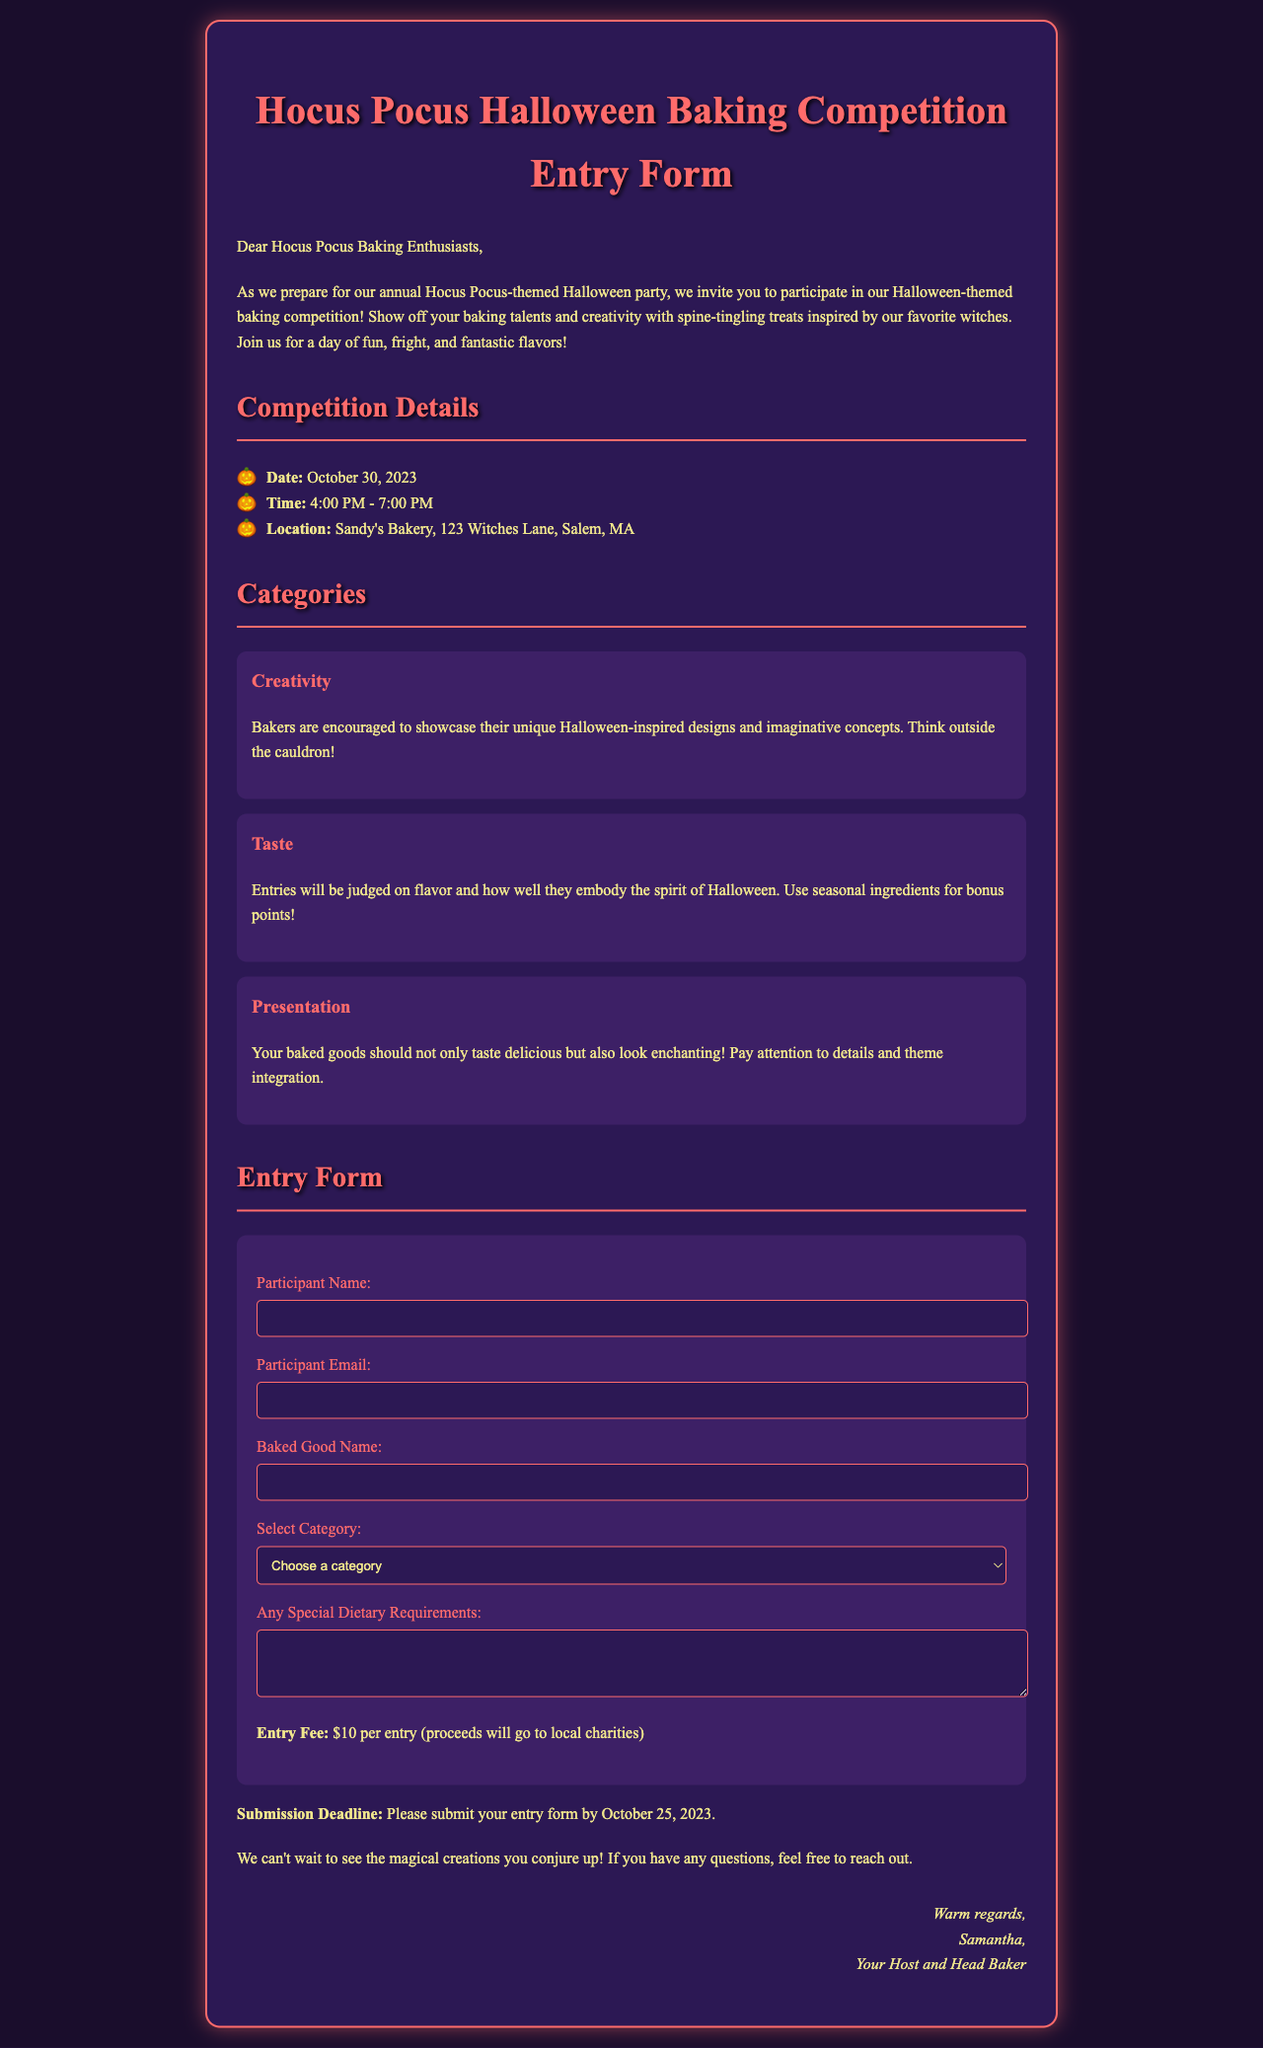What is the date of the competition? The competition is scheduled for October 30, 2023, as stated in the document.
Answer: October 30, 2023 What is the entry fee for the competition? The entry fee is mentioned as $10 per entry in the document.
Answer: $10 Where is the location of the baking competition? The competition will take place at Sandy's Bakery, as indicated in the document.
Answer: Sandy's Bakery, 123 Witches Lane, Salem, MA Who is the host of the event? The document states that Samantha is the host and head baker for the event.
Answer: Samantha What category focuses on the visual aesthetics of the baked goods? The category that emphasizes the appearance of baked goods is presentation, as detailed in the document.
Answer: Presentation What is the submission deadline for the entry form? The document specifies that the entry form must be submitted by October 25, 2023.
Answer: October 25, 2023 Which category rewards seasonal ingredient use? The category that rewards the use of seasonal ingredients is taste, according to the document.
Answer: Taste What should participants do if they have special dietary requirements? Participants are encouraged to mention any special dietary requirements in the special requests section of the entry form.
Answer: Mention in the special requests section 